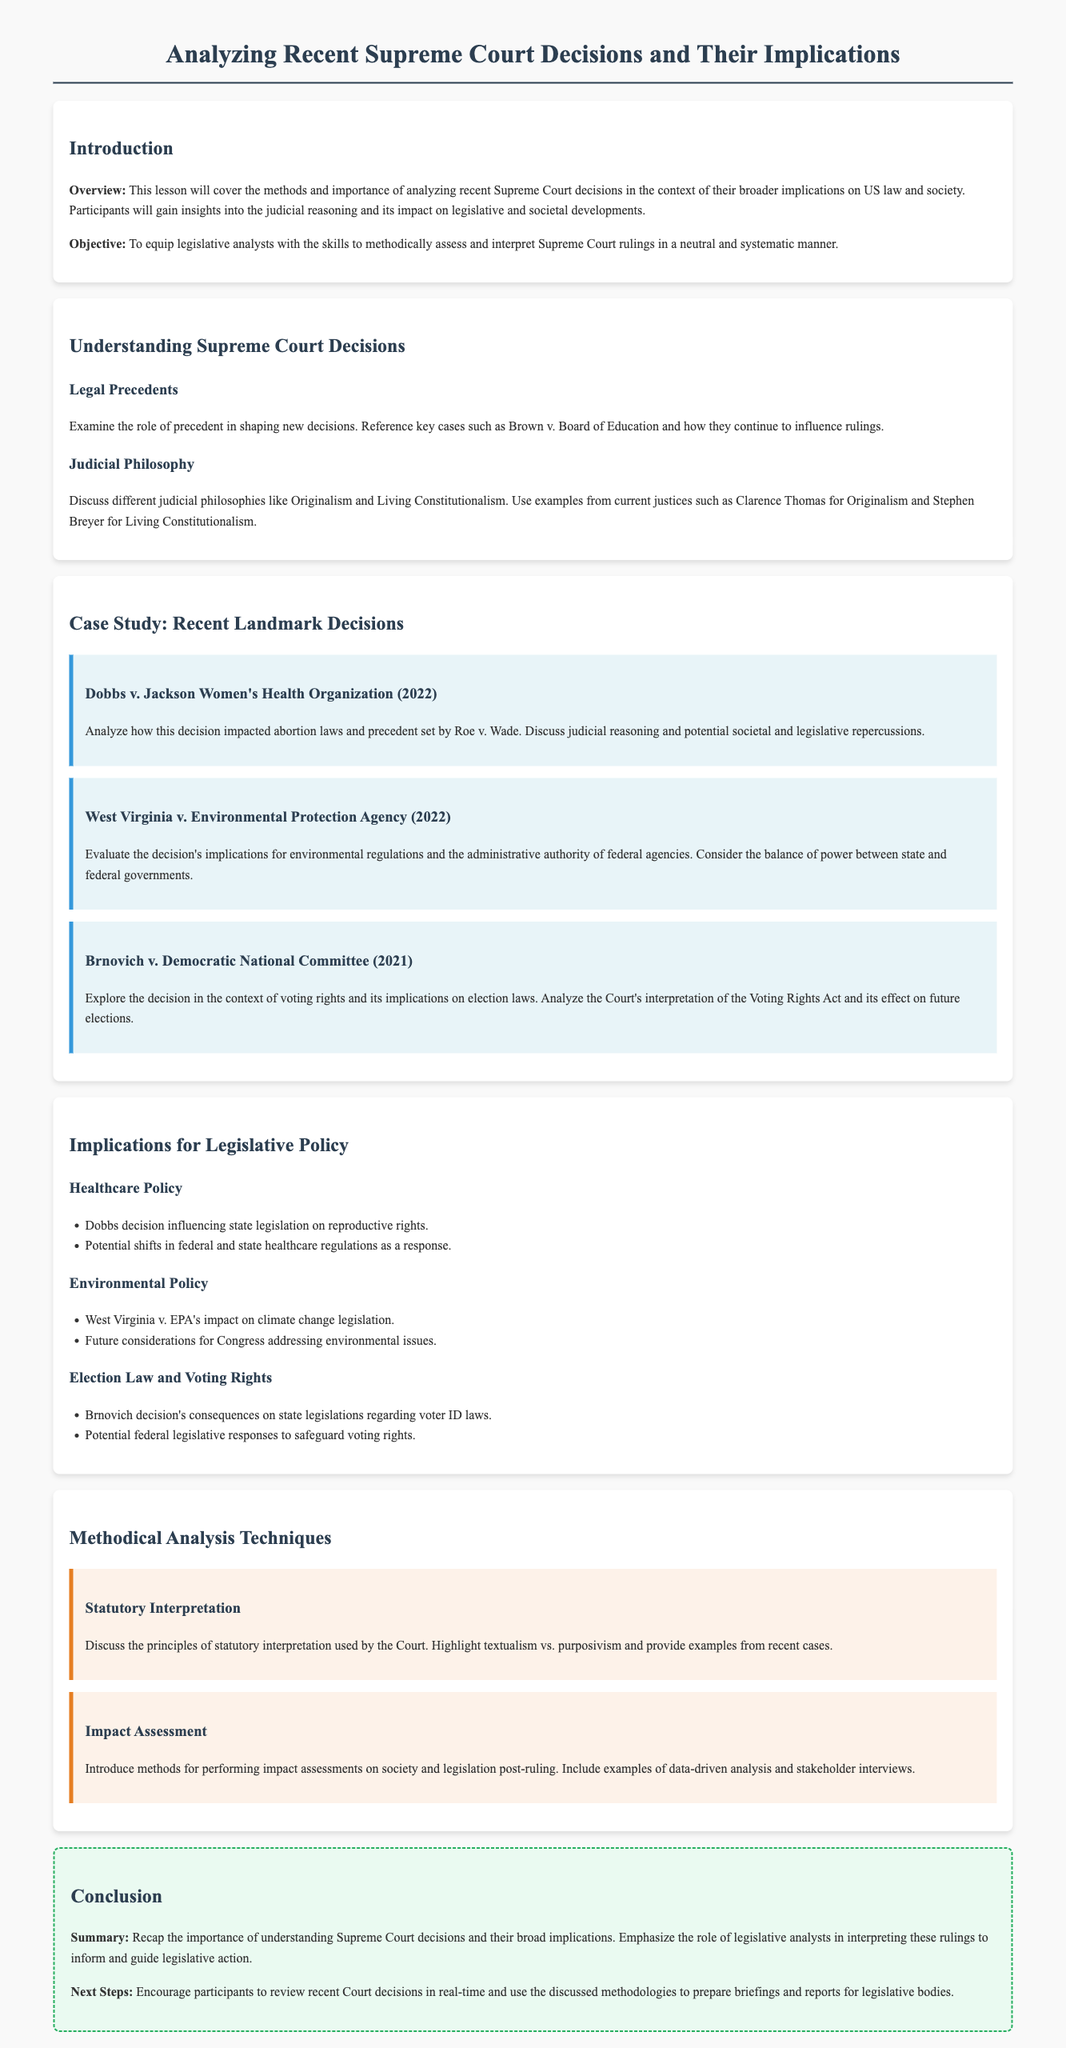What is the title of the lesson plan? The title provides an overview of the main topic covered in the document, which is about analyzing Supreme Court decisions.
Answer: Analyzing Recent Supreme Court Decisions and Their Implications What year did the Dobbs v. Jackson Women's Health Organization decision take place? The decision year is mentioned in the case study section under recent landmark decisions.
Answer: 2022 Who are the two justices associated with Originalism and Living Constitutionalism? The document provides examples of current justices who represent these judicial philosophies.
Answer: Clarence Thomas and Stephen Breyer What type of policy does the Brnovich v. Democratic National Committee decision primarily impact? The context of the Brnovich case relates specifically to voting rights and election laws.
Answer: Voting rights What are two methods mentioned for performing impact assessments? This question highlights the analytical methodologies discussed in the lesson plan.
Answer: Data-driven analysis and stakeholder interviews What are the two principles of statutory interpretation discussed? The document outlines different approaches to statutory interpretation that the Court uses.
Answer: Textualism and purposivism What is the objective of the lesson plan? The objective outlines what participants will gain from the lesson regarding Supreme Court rulings.
Answer: To equip legislative analysts with the skills to methodically assess and interpret Supreme Court rulings in a neutral and systematic manner What are the implications of the West Virginia v. EPA decision on climate change legislation? The decision's consequences are noted under the implications for legislative policy section.
Answer: Impact on climate change legislation What is emphasized in the conclusion section of the lesson plan? The conclusion summarizes the importance of understanding the decisions and roles of legislative analysts.
Answer: Understanding Supreme Court decisions and their broad implications 